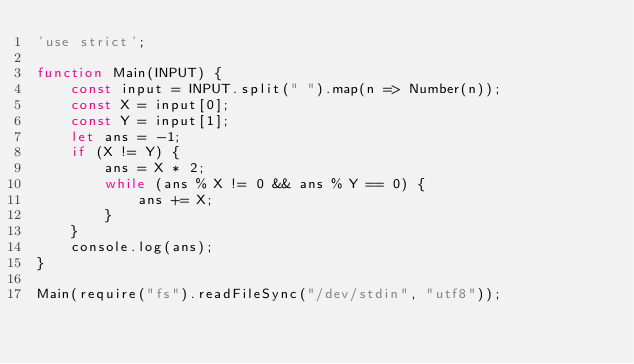<code> <loc_0><loc_0><loc_500><loc_500><_JavaScript_>'use strict';

function Main(INPUT) {
    const input = INPUT.split(" ").map(n => Number(n));
    const X = input[0];
    const Y = input[1];
    let ans = -1;
    if (X != Y) {
        ans = X * 2;
        while (ans % X != 0 && ans % Y == 0) {
            ans += X;
        }
    }
    console.log(ans);
}

Main(require("fs").readFileSync("/dev/stdin", "utf8"));
</code> 